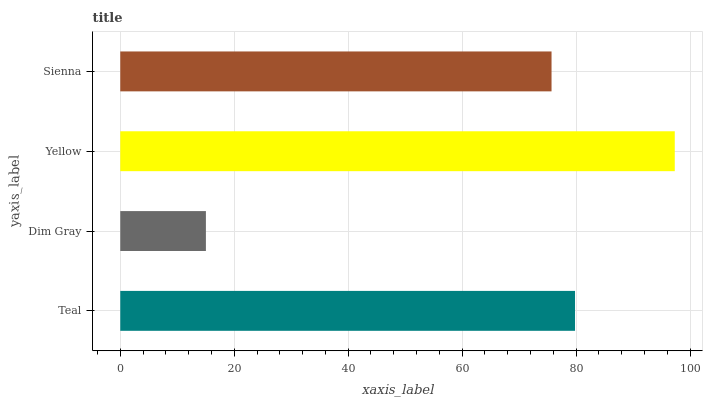Is Dim Gray the minimum?
Answer yes or no. Yes. Is Yellow the maximum?
Answer yes or no. Yes. Is Yellow the minimum?
Answer yes or no. No. Is Dim Gray the maximum?
Answer yes or no. No. Is Yellow greater than Dim Gray?
Answer yes or no. Yes. Is Dim Gray less than Yellow?
Answer yes or no. Yes. Is Dim Gray greater than Yellow?
Answer yes or no. No. Is Yellow less than Dim Gray?
Answer yes or no. No. Is Teal the high median?
Answer yes or no. Yes. Is Sienna the low median?
Answer yes or no. Yes. Is Yellow the high median?
Answer yes or no. No. Is Dim Gray the low median?
Answer yes or no. No. 